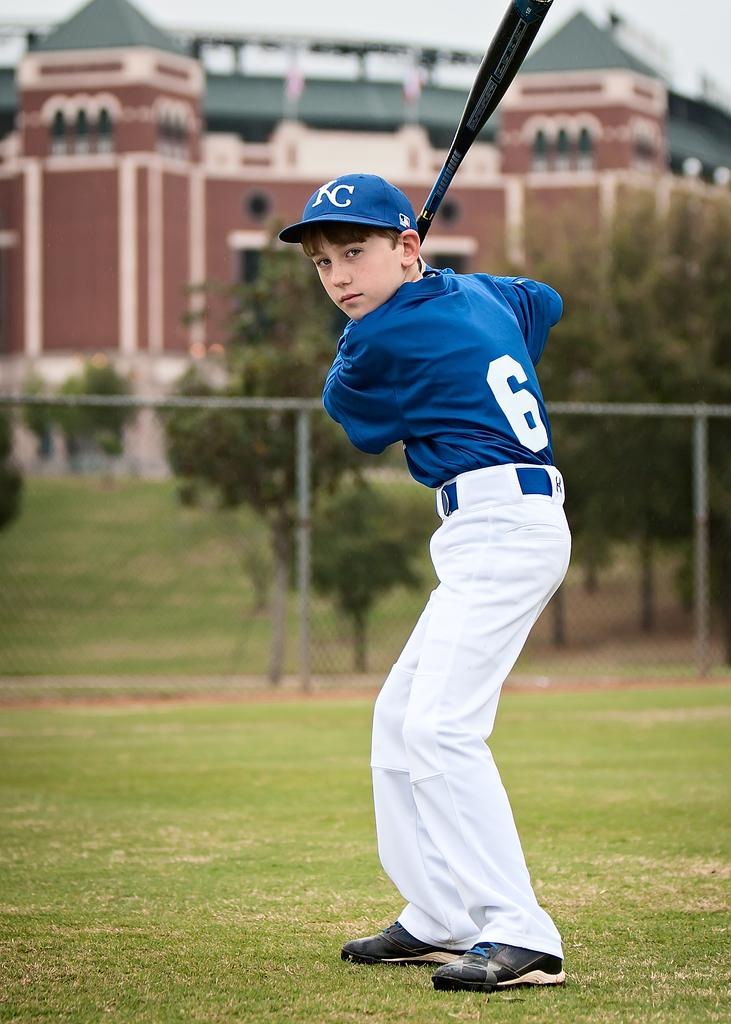<image>
Present a compact description of the photo's key features. Baseball player wearing a cap which says KC on it. 